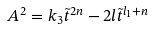<formula> <loc_0><loc_0><loc_500><loc_500>A ^ { 2 } = k _ { 3 } { \tilde { t } } ^ { 2 n } - 2 l { \tilde { t } } ^ { l _ { 1 } + n }</formula> 